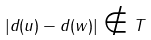<formula> <loc_0><loc_0><loc_500><loc_500>| d ( u ) - d ( w ) | \notin T</formula> 